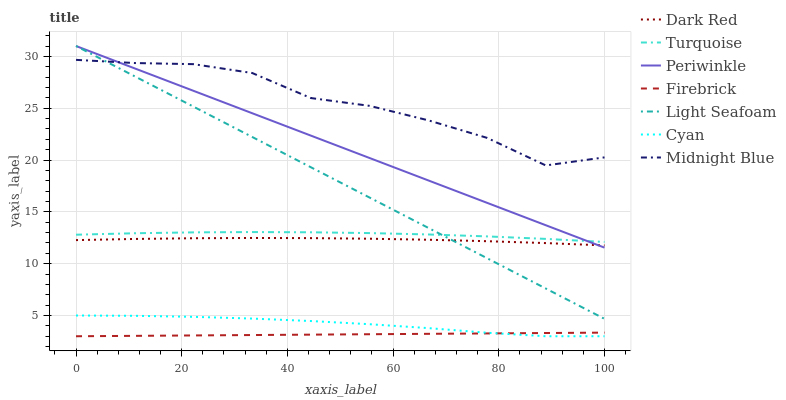Does Firebrick have the minimum area under the curve?
Answer yes or no. Yes. Does Midnight Blue have the maximum area under the curve?
Answer yes or no. Yes. Does Dark Red have the minimum area under the curve?
Answer yes or no. No. Does Dark Red have the maximum area under the curve?
Answer yes or no. No. Is Firebrick the smoothest?
Answer yes or no. Yes. Is Midnight Blue the roughest?
Answer yes or no. Yes. Is Dark Red the smoothest?
Answer yes or no. No. Is Dark Red the roughest?
Answer yes or no. No. Does Firebrick have the lowest value?
Answer yes or no. Yes. Does Dark Red have the lowest value?
Answer yes or no. No. Does Light Seafoam have the highest value?
Answer yes or no. Yes. Does Midnight Blue have the highest value?
Answer yes or no. No. Is Cyan less than Light Seafoam?
Answer yes or no. Yes. Is Turquoise greater than Dark Red?
Answer yes or no. Yes. Does Periwinkle intersect Light Seafoam?
Answer yes or no. Yes. Is Periwinkle less than Light Seafoam?
Answer yes or no. No. Is Periwinkle greater than Light Seafoam?
Answer yes or no. No. Does Cyan intersect Light Seafoam?
Answer yes or no. No. 